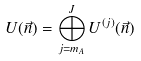<formula> <loc_0><loc_0><loc_500><loc_500>U ( \vec { n } ) = \bigoplus _ { j = m _ { A } } ^ { J } U ^ { ( j ) } ( \vec { n } )</formula> 